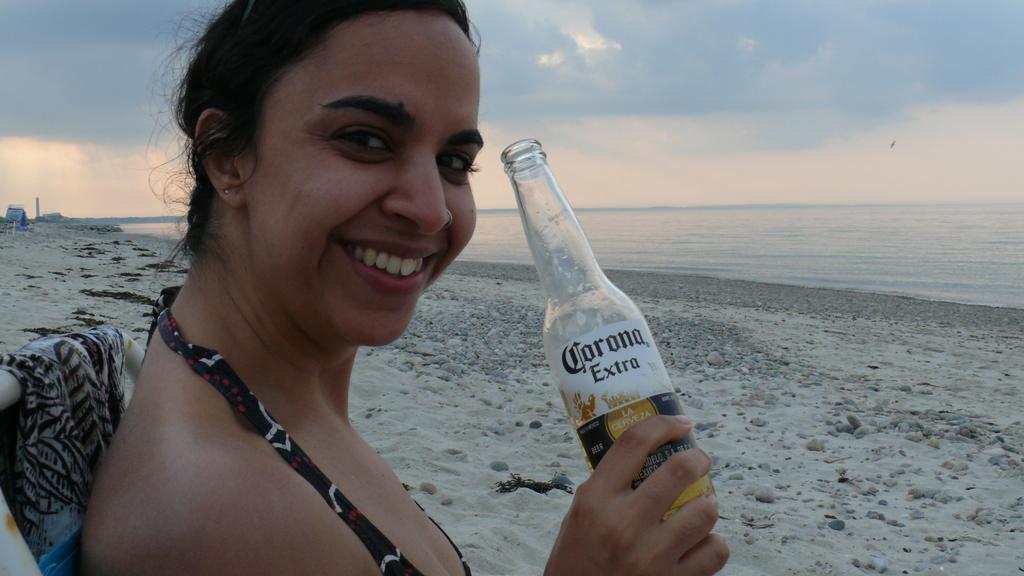Describe this image in one or two sentences. In this picture there is a woman who is holding a bottle in her hand and is smiling. She is sitting on the chair. There is a sand. There is a water. The sky is cloudy. 